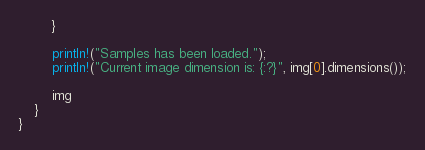<code> <loc_0><loc_0><loc_500><loc_500><_Rust_>        }
    
        println!("Samples has been loaded.");
        println!("Current image dimension is: {:?}", img[0].dimensions());
    
        img
    }
}
</code> 